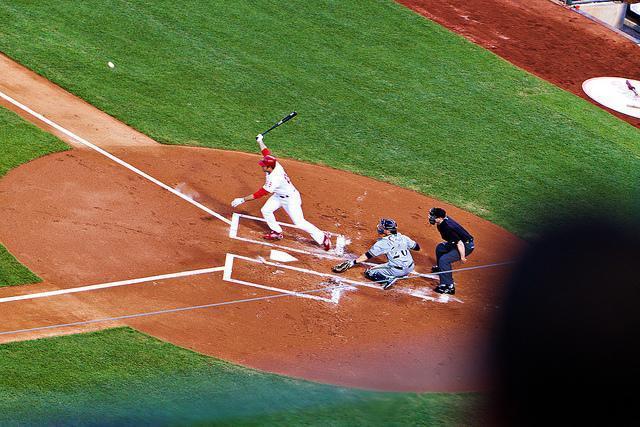How many people are there?
Give a very brief answer. 2. 